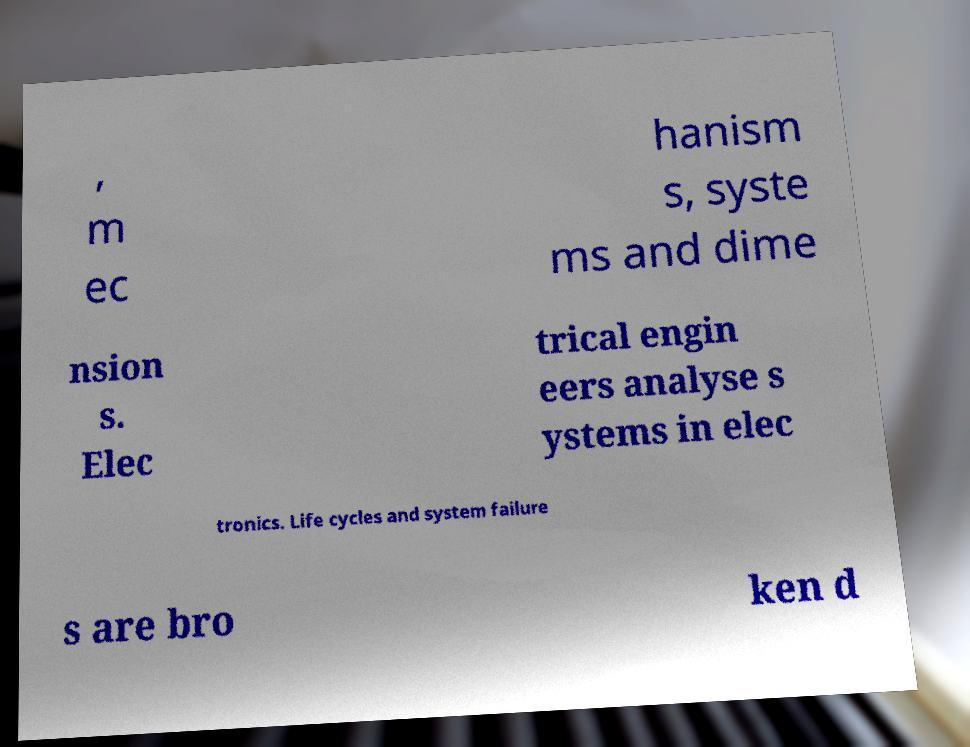Can you read and provide the text displayed in the image?This photo seems to have some interesting text. Can you extract and type it out for me? , m ec hanism s, syste ms and dime nsion s. Elec trical engin eers analyse s ystems in elec tronics. Life cycles and system failure s are bro ken d 